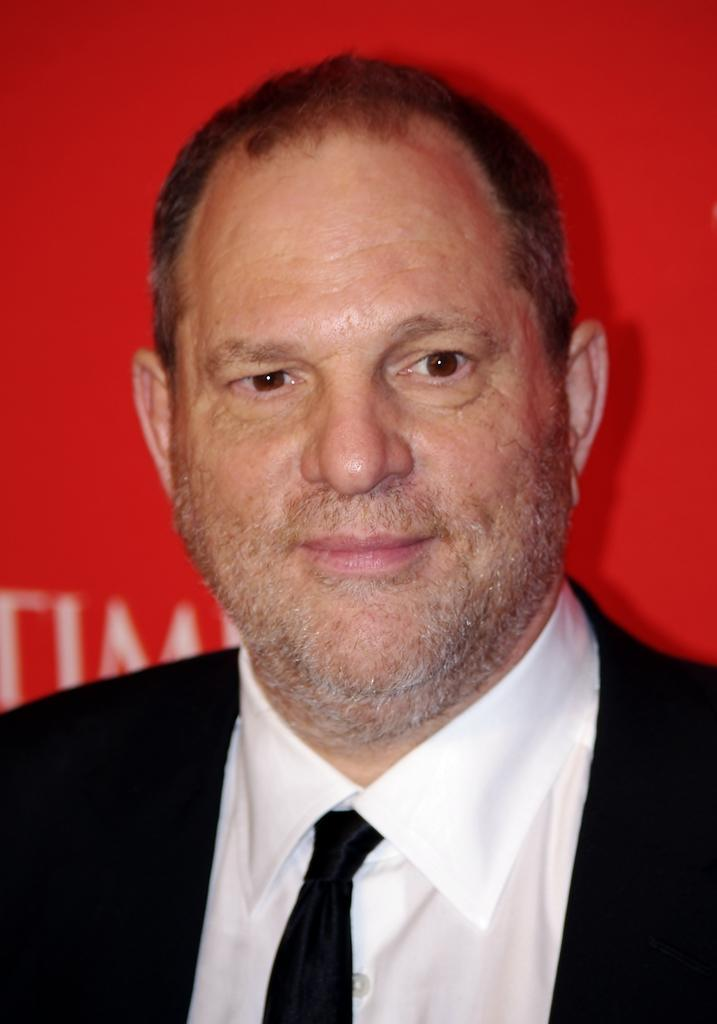Who is the main subject in the image? There is a man in the center of the image. What is the man doing in the image? The man is smiling. What can be seen in the background of the image? There is a red color banner in the background of the image. What is written on the banner? Text is written on the banner. What type of jewel is the maid holding in the image? There is no maid or jewel present in the image. How many grains of rice are visible on the man's shirt in the image? There is no mention of rice or grains in the image, and no indication that any are visible on the man's shirt. 